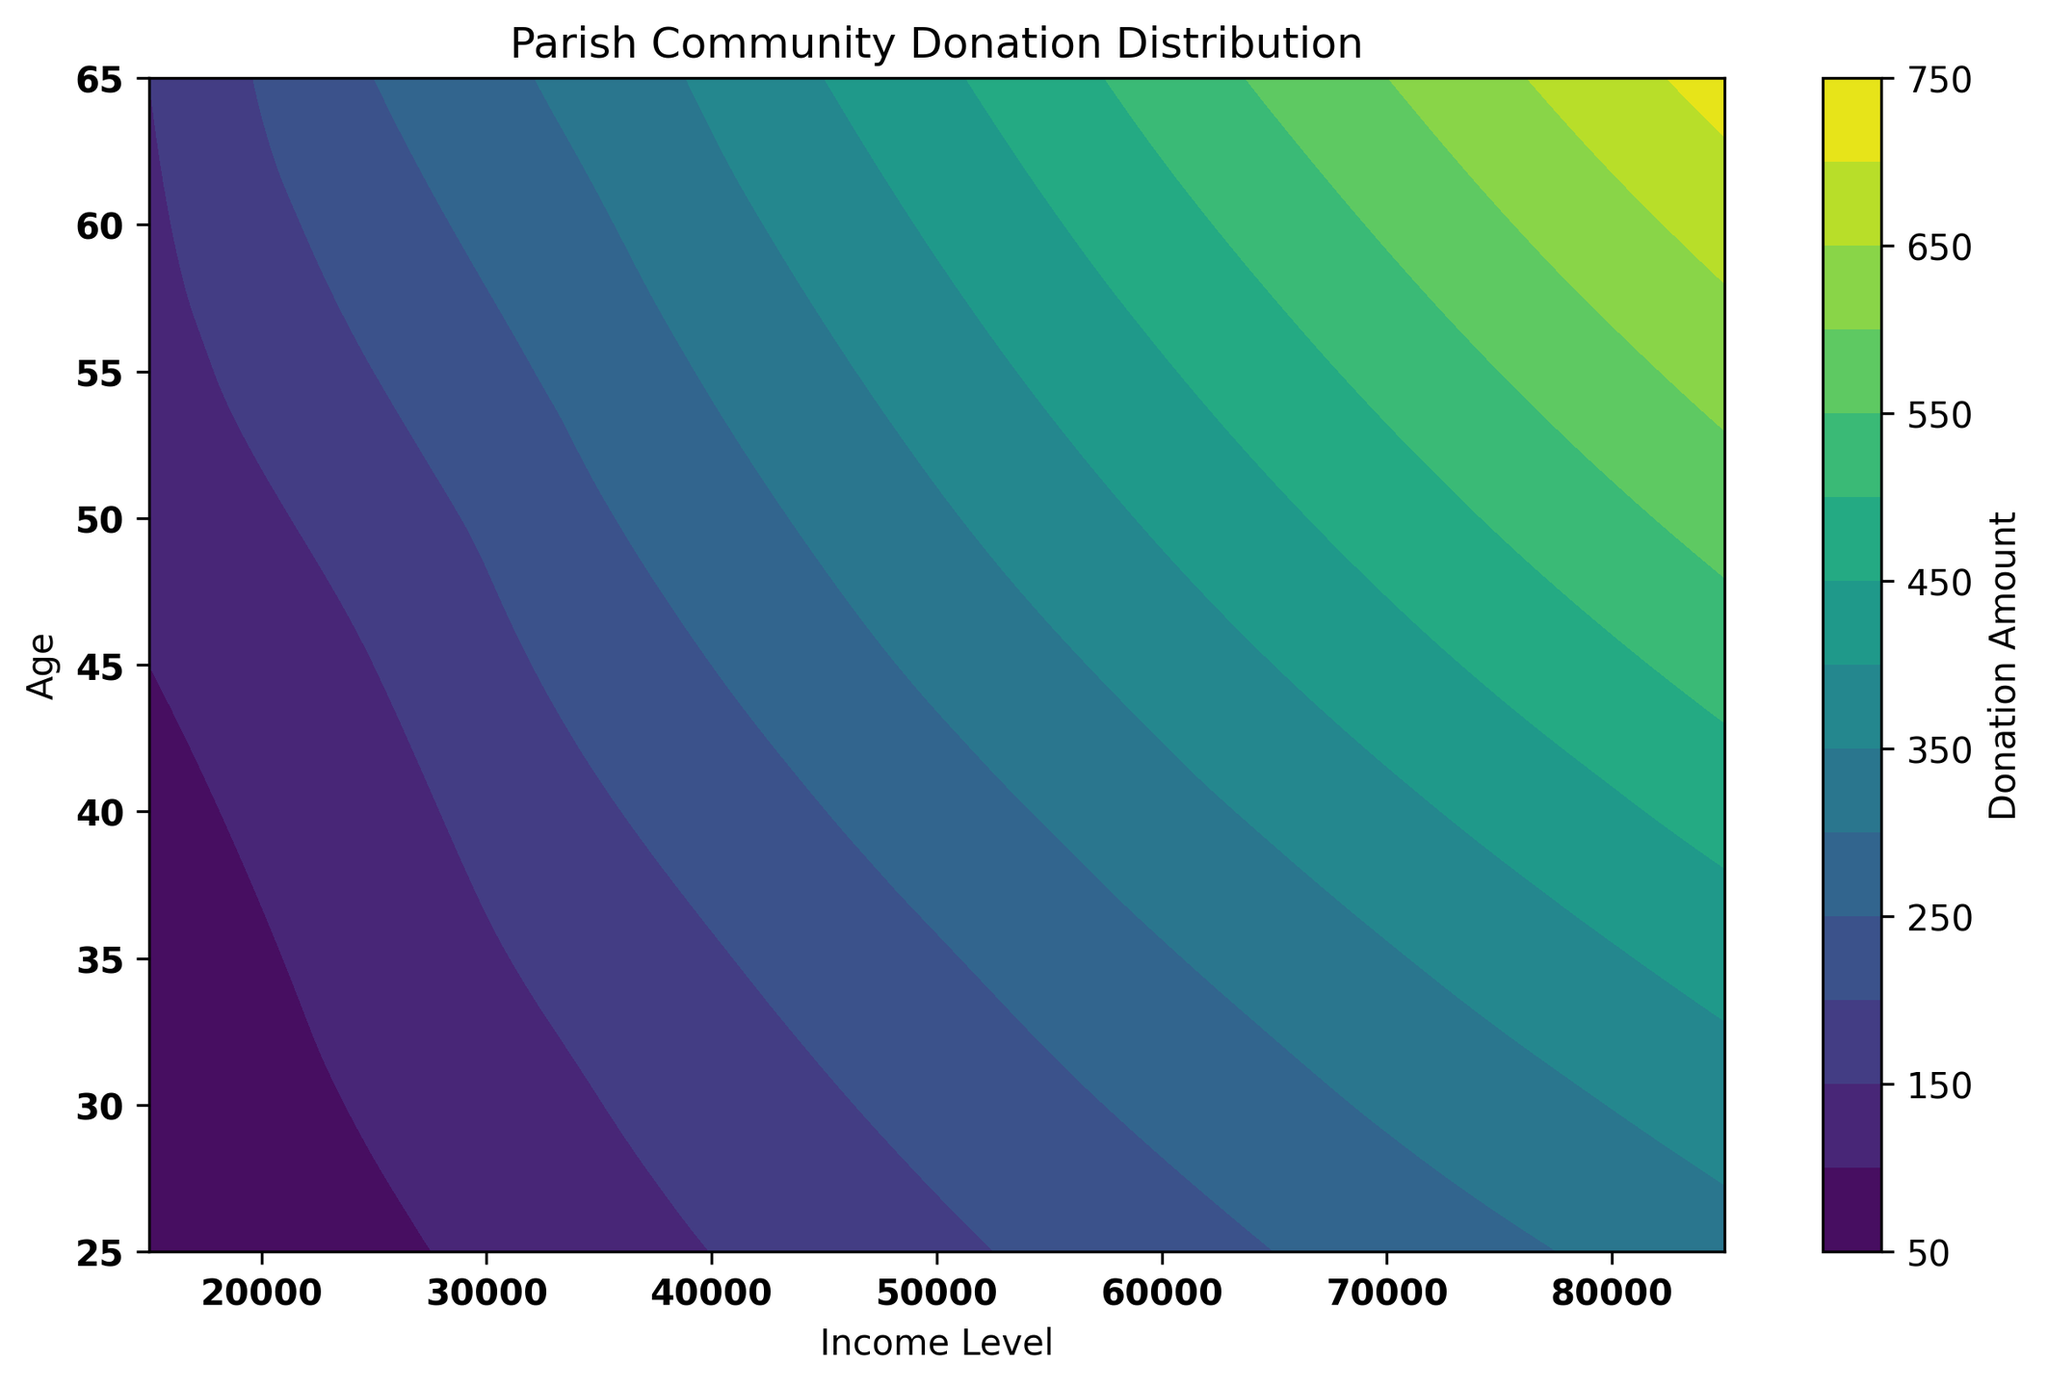What's the highest donation amount for the 45-year-old age group across all income levels? Look at the contour plot and find the highest value on the Donation Amount color scale within the 45-year-old horizontal line.
Answer: 520 Where do we observe the highest average donations: in the lower (25-45) or upper (55-65) age range? Determine the average donation amount for each age group (25, 35, 45, 55, 65). Compare the averages: (50+70+100)/3 for lower and (130+150)/2 for upper.
Answer: Upper (55-65) Which income level sees the steepest increase in donations as age increases? Compare the gradient of donation amounts across different ages for each income level. Notice the steepest contours for higher donations.
Answer: 85,000 For the income level of 65,000, how does the donation amount range with age? Follow the vertical income line at 65,000 and observe the colors changing as age increases from 25 to 65. Lowest is 250 and highest is 560.
Answer: From 250 to 560 At what income level do donations consistently exceed 300 across all ages? Use the contour plot to identify the income level where the donation amount contour line for 300 appears continuously between ages 25 and 65.
Answer: 75,000 What is the average donation amount for the 35-year-old age group across all income levels? Add the donation amounts for 35-year-old across all income levels (70+120+170+220+270+320+370+420) and divide by 8.
Answer: 245 Comparing age groups 25 and 65, which group has a broader range of donation amounts? Note the donation amounts for the age groups 25 and 65 across all income levels and calculate the range (max - min for each age group).
Answer: 65 (640-720) 